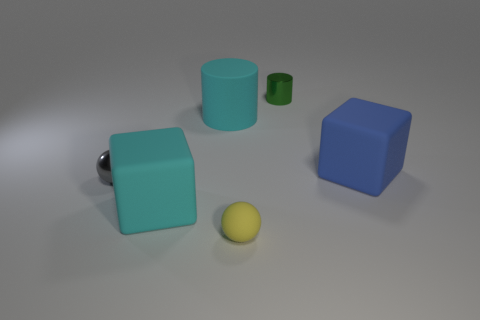Is the color of the rubber cylinder the same as the rubber sphere?
Provide a succinct answer. No. Is there any other thing that has the same shape as the blue object?
Your answer should be compact. Yes. There is a cube that is the same color as the large cylinder; what is it made of?
Ensure brevity in your answer.  Rubber. Are there the same number of small green cylinders that are in front of the small gray metallic sphere and tiny red balls?
Your answer should be compact. Yes. Are there any big matte cubes on the left side of the big cyan matte cube?
Give a very brief answer. No. Does the green metallic object have the same shape as the cyan matte thing that is behind the gray metallic ball?
Offer a very short reply. Yes. What is the color of the sphere that is the same material as the tiny green object?
Your answer should be very brief. Gray. What is the color of the matte cylinder?
Make the answer very short. Cyan. Is the tiny cylinder made of the same material as the block behind the large cyan cube?
Your answer should be very brief. No. How many large objects are both in front of the blue cube and behind the large blue cube?
Offer a very short reply. 0. 